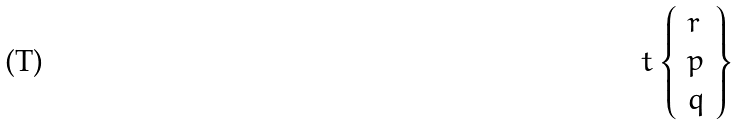Convert formula to latex. <formula><loc_0><loc_0><loc_500><loc_500>t \left \{ { \begin{array} { l } { r } \\ { p } \\ { q } \end{array} } \right \}</formula> 